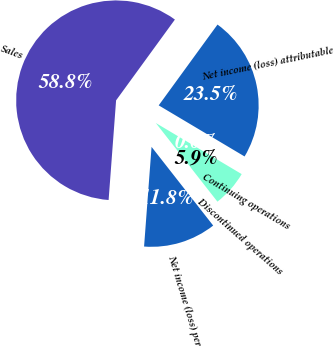Convert chart to OTSL. <chart><loc_0><loc_0><loc_500><loc_500><pie_chart><fcel>Sales<fcel>Net income (loss) attributable<fcel>Continuing operations<fcel>Discontinued operations<fcel>Net income (loss) per<nl><fcel>58.82%<fcel>23.53%<fcel>0.0%<fcel>5.88%<fcel>11.77%<nl></chart> 